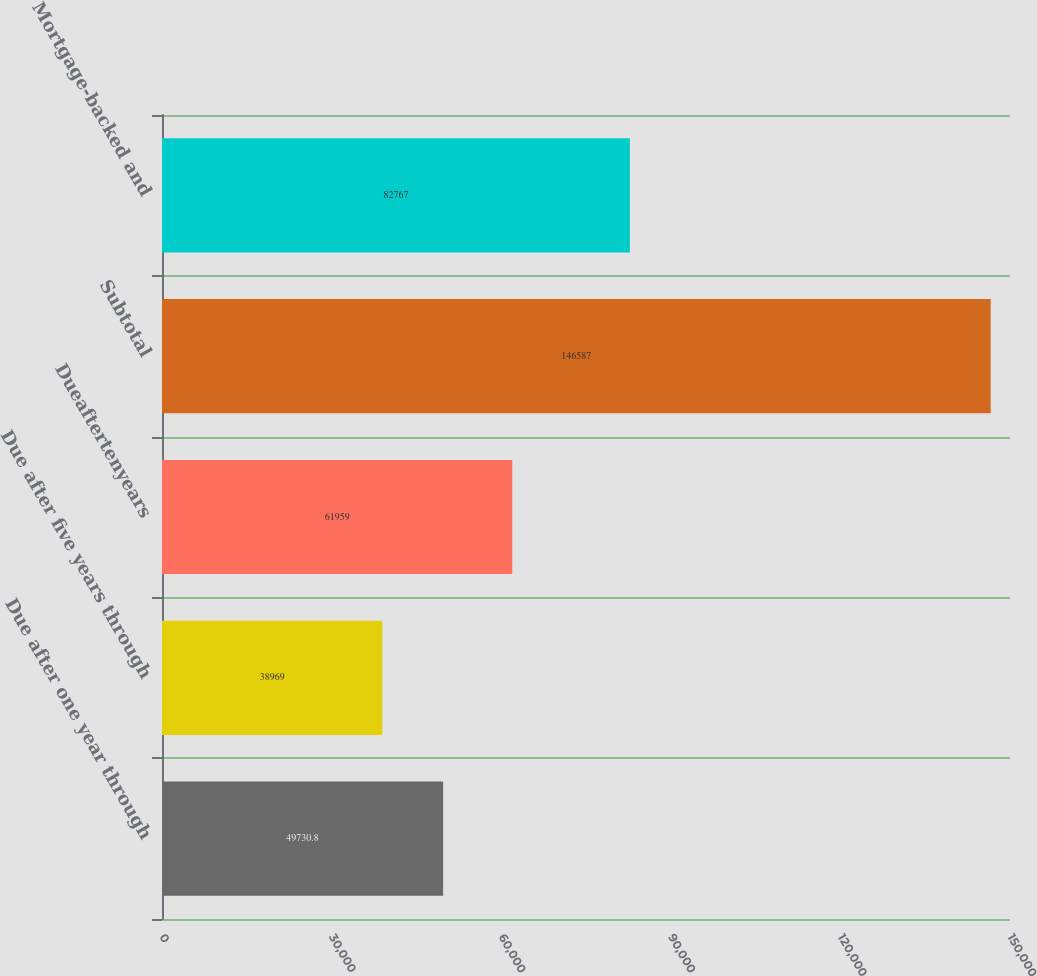Convert chart to OTSL. <chart><loc_0><loc_0><loc_500><loc_500><bar_chart><fcel>Due after one year through<fcel>Due after five years through<fcel>Dueaftertenyears<fcel>Subtotal<fcel>Mortgage-backed and<nl><fcel>49730.8<fcel>38969<fcel>61959<fcel>146587<fcel>82767<nl></chart> 